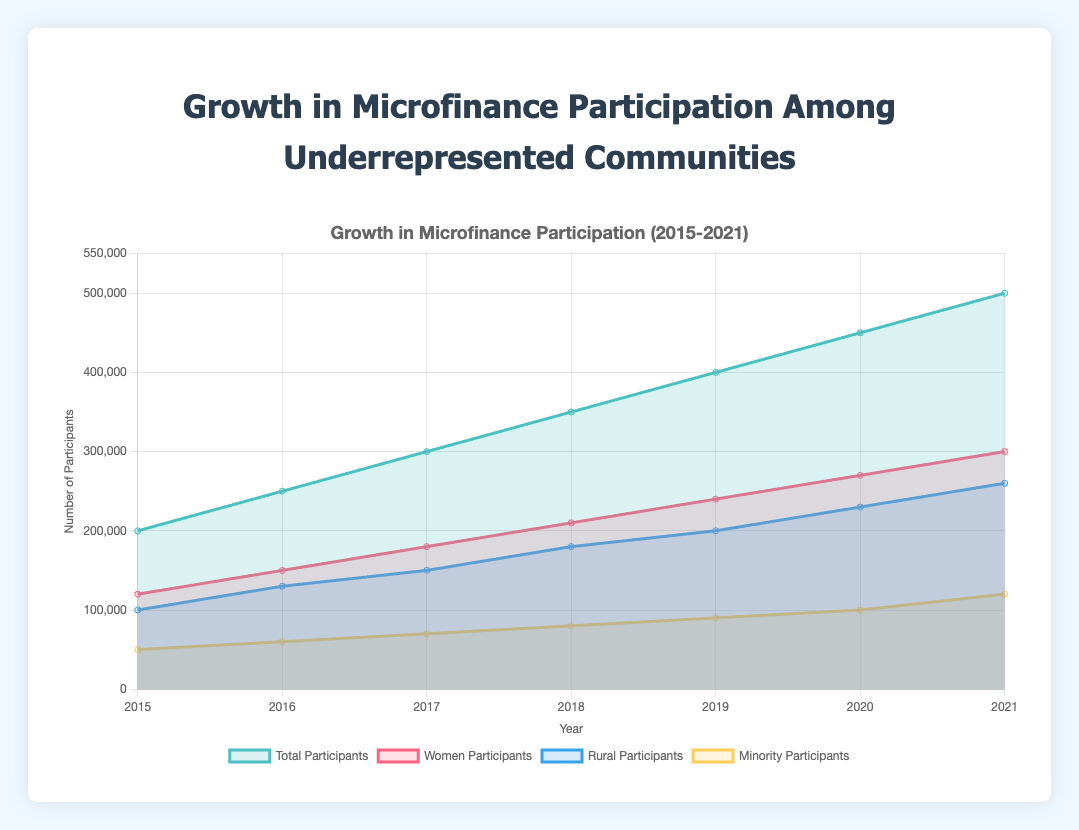What is the title of the chart? The title of the chart is displayed at the top and it's clear and centered.
Answer: Growth in Microfinance Participation Among Underrepresented Communities How many years of data are shown in the chart? The x-axis labels represent the years, and we can count each distinct year.
Answer: 7 Which participant group had the highest number in 2021? By looking at the y-values for each data point in 2021, we can compare the four groups.
Answer: Women Participants What is the color used to represent Rural Participants? By examining the chart's legend, the color associated with Rural Participants can be identified.
Answer: Blue What is the total number of participants in 2020? The y-value for Total Participants in 2020 can be found directly on the chart.
Answer: 450,000 What is the increase in Minority Participants from 2015 to 2021? Subtract the number of Minority Participants in 2015 from the number in 2021.
Answer: 70,000 How has the number of Women Participants changed from 2015 to 2021? Subtract the number of Women Participants in 2015 from the number in 2021 to see the change.
Answer: Increased by 180,000 Compare the growth rates of Rural Participants and Total Participants from 2015 to 2019. Calculate the growth rate for each group (2019 value - 2015 value) / 2015 value and compare. Rural Growth Rate: (200,000 - 100,000) / 100,000 = 100%. Total Growth Rate: (400,000 - 200,000) / 200,000 = 100%. Both have the same growth rate explanation.
Answer: Both had a 100% growth rate What year saw the largest increase in Total Participants compared to the previous year? Subtract the previous year’s Total Participants from each year’s Total Participants and identify the highest difference. 2016 - 2015: 50,000, 2017 - 2016: 50,000, 2018 - 2017: 50,000, 2019 - 2018: 50,000, 2020 - 2019: 50,000, 2021 - 2020: 50,000
Answer: 2016 